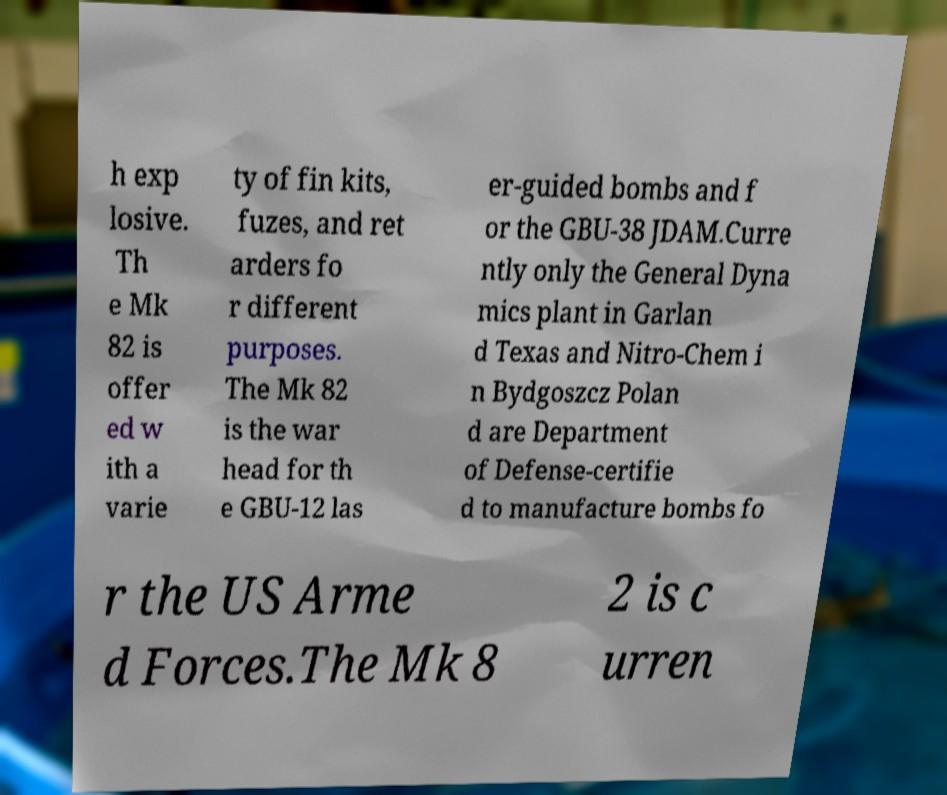Can you accurately transcribe the text from the provided image for me? h exp losive. Th e Mk 82 is offer ed w ith a varie ty of fin kits, fuzes, and ret arders fo r different purposes. The Mk 82 is the war head for th e GBU-12 las er-guided bombs and f or the GBU-38 JDAM.Curre ntly only the General Dyna mics plant in Garlan d Texas and Nitro-Chem i n Bydgoszcz Polan d are Department of Defense-certifie d to manufacture bombs fo r the US Arme d Forces.The Mk 8 2 is c urren 